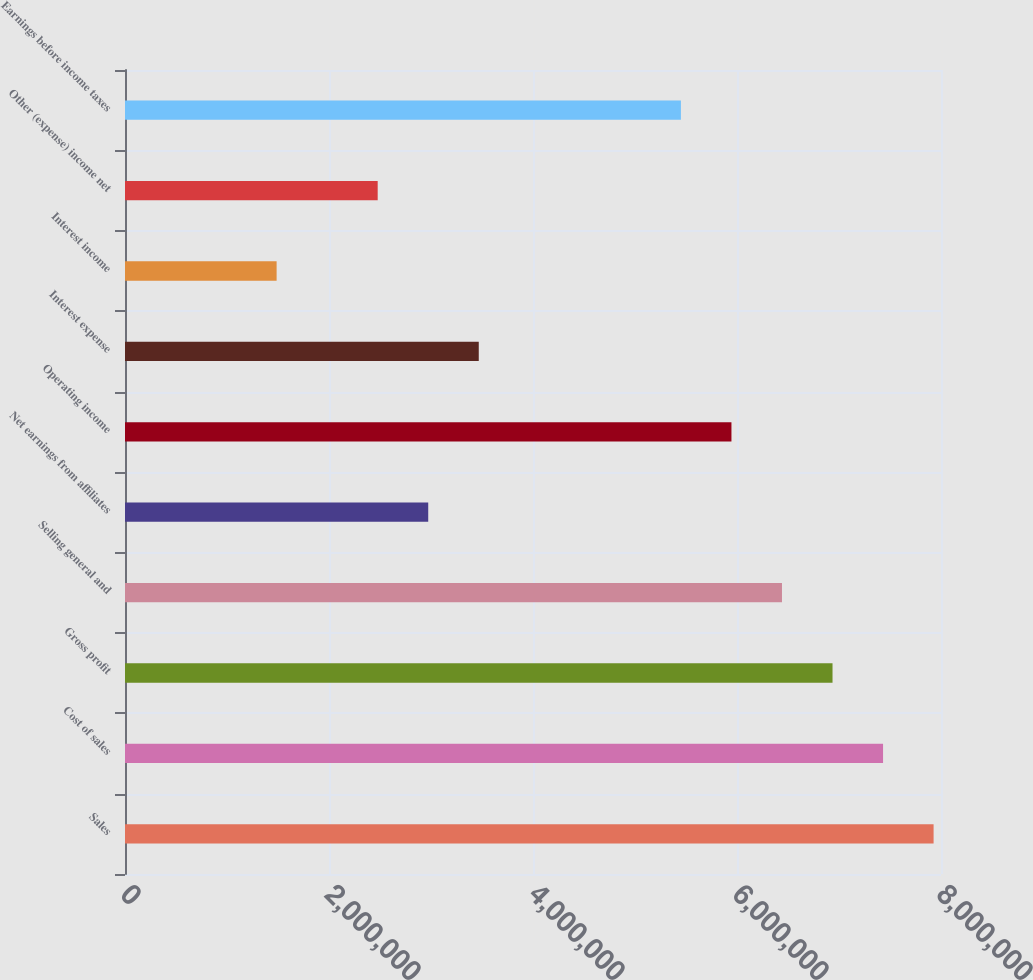Convert chart. <chart><loc_0><loc_0><loc_500><loc_500><bar_chart><fcel>Sales<fcel>Cost of sales<fcel>Gross profit<fcel>Selling general and<fcel>Net earnings from affiliates<fcel>Operating income<fcel>Interest expense<fcel>Interest income<fcel>Other (expense) income net<fcel>Earnings before income taxes<nl><fcel>7.92739e+06<fcel>7.43193e+06<fcel>6.93647e+06<fcel>6.441e+06<fcel>2.97277e+06<fcel>5.94554e+06<fcel>3.46823e+06<fcel>1.48639e+06<fcel>2.47731e+06<fcel>5.45008e+06<nl></chart> 